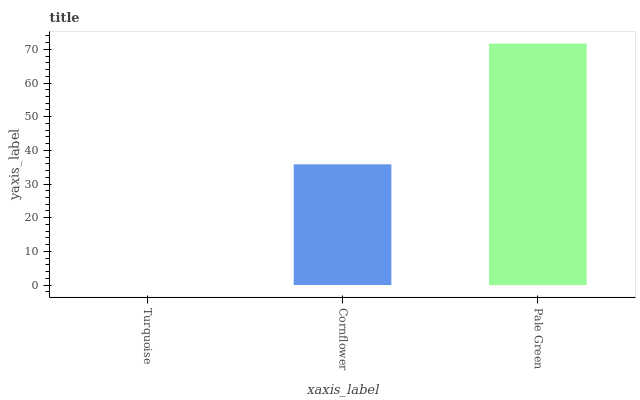Is Turquoise the minimum?
Answer yes or no. Yes. Is Pale Green the maximum?
Answer yes or no. Yes. Is Cornflower the minimum?
Answer yes or no. No. Is Cornflower the maximum?
Answer yes or no. No. Is Cornflower greater than Turquoise?
Answer yes or no. Yes. Is Turquoise less than Cornflower?
Answer yes or no. Yes. Is Turquoise greater than Cornflower?
Answer yes or no. No. Is Cornflower less than Turquoise?
Answer yes or no. No. Is Cornflower the high median?
Answer yes or no. Yes. Is Cornflower the low median?
Answer yes or no. Yes. Is Turquoise the high median?
Answer yes or no. No. Is Pale Green the low median?
Answer yes or no. No. 